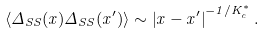Convert formula to latex. <formula><loc_0><loc_0><loc_500><loc_500>\langle \Delta _ { S S } ( x ) \Delta _ { S S } ( x ^ { \prime } ) \rangle \sim \left | x - x ^ { \prime } \right | ^ { - 1 / K ^ { \ast } _ { c } } .</formula> 